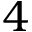Convert formula to latex. <formula><loc_0><loc_0><loc_500><loc_500>4</formula> 